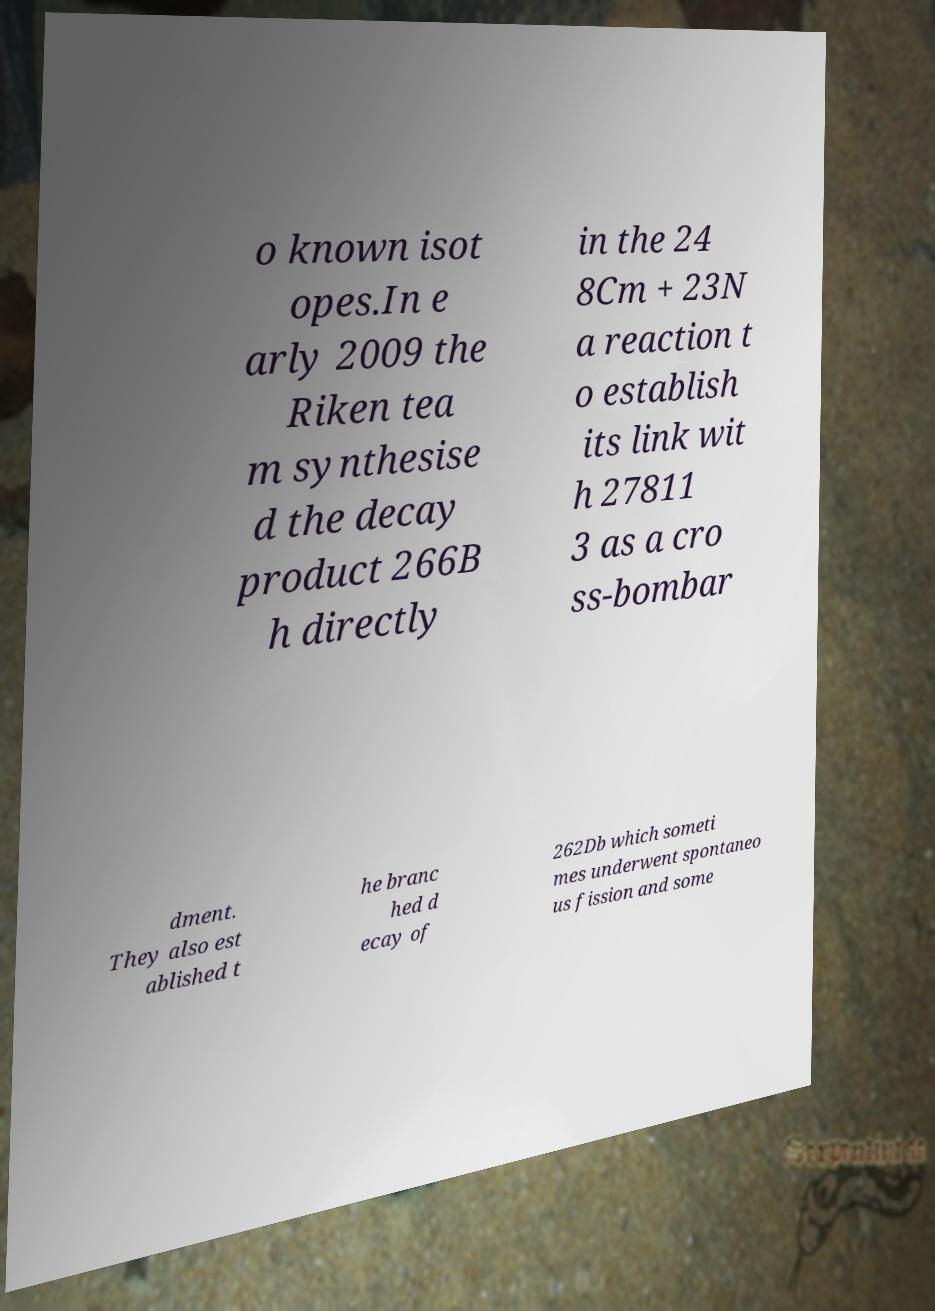Please identify and transcribe the text found in this image. o known isot opes.In e arly 2009 the Riken tea m synthesise d the decay product 266B h directly in the 24 8Cm + 23N a reaction t o establish its link wit h 27811 3 as a cro ss-bombar dment. They also est ablished t he branc hed d ecay of 262Db which someti mes underwent spontaneo us fission and some 